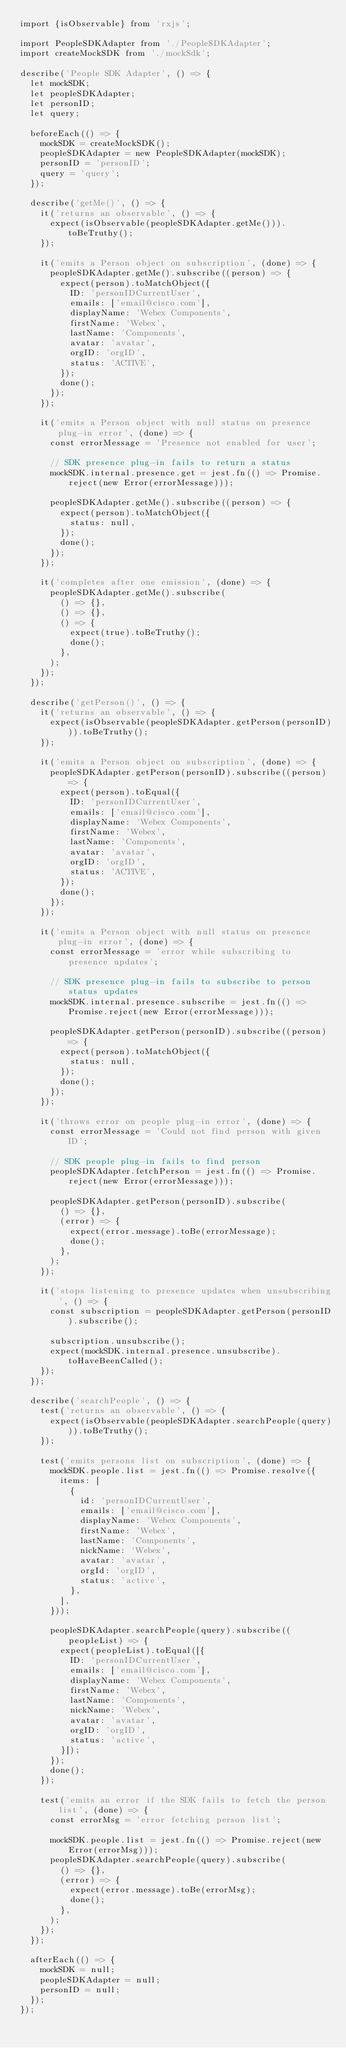Convert code to text. <code><loc_0><loc_0><loc_500><loc_500><_JavaScript_>import {isObservable} from 'rxjs';

import PeopleSDKAdapter from './PeopleSDKAdapter';
import createMockSDK from './mockSdk';

describe('People SDK Adapter', () => {
  let mockSDK;
  let peopleSDKAdapter;
  let personID;
  let query;

  beforeEach(() => {
    mockSDK = createMockSDK();
    peopleSDKAdapter = new PeopleSDKAdapter(mockSDK);
    personID = 'personID';
    query = 'query';
  });

  describe('getMe()', () => {
    it('returns an observable', () => {
      expect(isObservable(peopleSDKAdapter.getMe())).toBeTruthy();
    });

    it('emits a Person object on subscription', (done) => {
      peopleSDKAdapter.getMe().subscribe((person) => {
        expect(person).toMatchObject({
          ID: 'personIDCurrentUser',
          emails: ['email@cisco.com'],
          displayName: 'Webex Components',
          firstName: 'Webex',
          lastName: 'Components',
          avatar: 'avatar',
          orgID: 'orgID',
          status: 'ACTIVE',
        });
        done();
      });
    });

    it('emits a Person object with null status on presence plug-in error', (done) => {
      const errorMessage = 'Presence not enabled for user';

      // SDK presence plug-in fails to return a status
      mockSDK.internal.presence.get = jest.fn(() => Promise.reject(new Error(errorMessage)));

      peopleSDKAdapter.getMe().subscribe((person) => {
        expect(person).toMatchObject({
          status: null,
        });
        done();
      });
    });

    it('completes after one emission', (done) => {
      peopleSDKAdapter.getMe().subscribe(
        () => {},
        () => {},
        () => {
          expect(true).toBeTruthy();
          done();
        },
      );
    });
  });

  describe('getPerson()', () => {
    it('returns an observable', () => {
      expect(isObservable(peopleSDKAdapter.getPerson(personID))).toBeTruthy();
    });

    it('emits a Person object on subscription', (done) => {
      peopleSDKAdapter.getPerson(personID).subscribe((person) => {
        expect(person).toEqual({
          ID: 'personIDCurrentUser',
          emails: ['email@cisco.com'],
          displayName: 'Webex Components',
          firstName: 'Webex',
          lastName: 'Components',
          avatar: 'avatar',
          orgID: 'orgID',
          status: 'ACTIVE',
        });
        done();
      });
    });

    it('emits a Person object with null status on presence plug-in error', (done) => {
      const errorMessage = 'error while subscribing to presence updates';

      // SDK presence plug-in fails to subscribe to person status updates
      mockSDK.internal.presence.subscribe = jest.fn(() => Promise.reject(new Error(errorMessage)));

      peopleSDKAdapter.getPerson(personID).subscribe((person) => {
        expect(person).toMatchObject({
          status: null,
        });
        done();
      });
    });

    it('throws error on people plug-in error', (done) => {
      const errorMessage = 'Could not find person with given ID';

      // SDK people plug-in fails to find person
      peopleSDKAdapter.fetchPerson = jest.fn(() => Promise.reject(new Error(errorMessage)));

      peopleSDKAdapter.getPerson(personID).subscribe(
        () => {},
        (error) => {
          expect(error.message).toBe(errorMessage);
          done();
        },
      );
    });

    it('stops listening to presence updates when unsubscribing', () => {
      const subscription = peopleSDKAdapter.getPerson(personID).subscribe();

      subscription.unsubscribe();
      expect(mockSDK.internal.presence.unsubscribe).toHaveBeenCalled();
    });
  });

  describe('searchPeople', () => {
    test('returns an observable', () => {
      expect(isObservable(peopleSDKAdapter.searchPeople(query))).toBeTruthy();
    });

    test('emits persons list on subscription', (done) => {
      mockSDK.people.list = jest.fn(() => Promise.resolve({
        items: [
          {
            id: 'personIDCurrentUser',
            emails: ['email@cisco.com'],
            displayName: 'Webex Components',
            firstName: 'Webex',
            lastName: 'Components',
            nickName: 'Webex',
            avatar: 'avatar',
            orgId: 'orgID',
            status: 'active',
          },
        ],
      }));

      peopleSDKAdapter.searchPeople(query).subscribe((peopleList) => {
        expect(peopleList).toEqual([{
          ID: 'personIDCurrentUser',
          emails: ['email@cisco.com'],
          displayName: 'Webex Components',
          firstName: 'Webex',
          lastName: 'Components',
          nickName: 'Webex',
          avatar: 'avatar',
          orgID: 'orgID',
          status: 'active',
        }]);
      });
      done();
    });

    test('emits an error if the SDK fails to fetch the person list', (done) => {
      const errorMsg = 'error fetching person list';

      mockSDK.people.list = jest.fn(() => Promise.reject(new Error(errorMsg)));
      peopleSDKAdapter.searchPeople(query).subscribe(
        () => {},
        (error) => {
          expect(error.message).toBe(errorMsg);
          done();
        },
      );
    });
  });

  afterEach(() => {
    mockSDK = null;
    peopleSDKAdapter = null;
    personID = null;
  });
});
</code> 